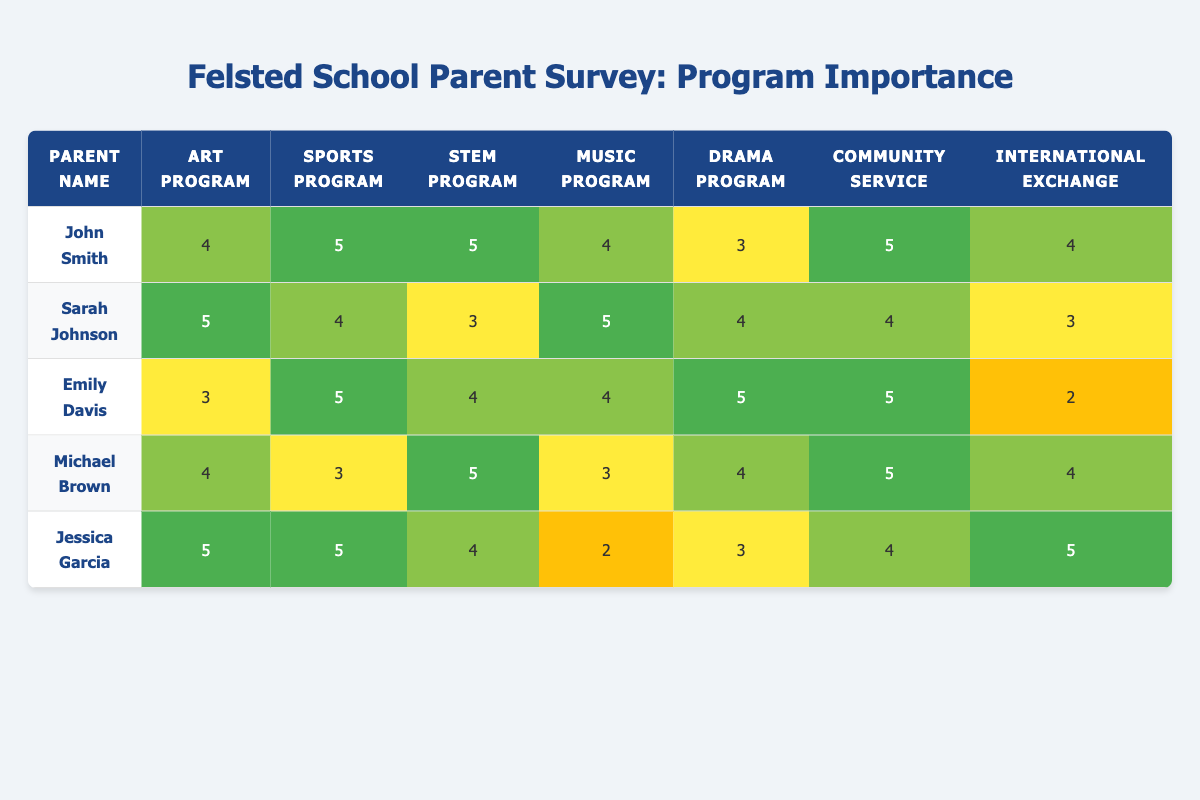What is the highest importance rating for the Art Program? Looking at the Art Program's importance ratings, the highest is from Sarah Johnson with a rating of 5.
Answer: 5 What importance rating did John Smith give to the Music Program? John Smith rated the Music Program with a score of 4.
Answer: 4 Are there any parents who rated the International Exchange Program with a score of 2? Yes, Emily Davis rated the International Exchange Program with a score of 2.
Answer: Yes What is the average rating for the Sports Program among all parents? The Sports Program ratings are 5, 4, 5, 3, and 5. Summing these gives 22, and there are 5 parents, so the average is 22/5 = 4.4.
Answer: 4.4 Did any parents rate the Drama Program higher than 4? Yes, Emily Davis rated the Drama Program with a score of 5, which is higher than 4.
Answer: Yes What is the total importance score for Community Service summed across all parents? The ratings for Community Service are 5, 4, 5, 5, and 4. Adding these gives 5 + 4 + 5 + 5 + 4 = 23.
Answer: 23 Which parent gave the lowest rating for the International Exchange Program? Emily Davis rated the International Exchange Program with a score of 2, which is the lowest among all ratings.
Answer: Emily Davis How many parents rated the Sports Program with a score of 5? The parents who rated the Sports Program with a score of 5 are John Smith, Emily Davis, and Jessica Garcia, totaling 3 parents.
Answer: 3 What is the difference between the highest and lowest ratings for the STEM Program? The highest rating for the STEM Program is 5 (by John Smith, Michael Brown, and Jessica Garcia) and the lowest is 3 (by Sarah Johnson). The difference is 5 - 3 = 2.
Answer: 2 Which parent values Community Service the most based on their rating? John Smith and Emily Davis both rated Community Service as 5, which is the highest, so both value it the most.
Answer: John Smith and Emily Davis 